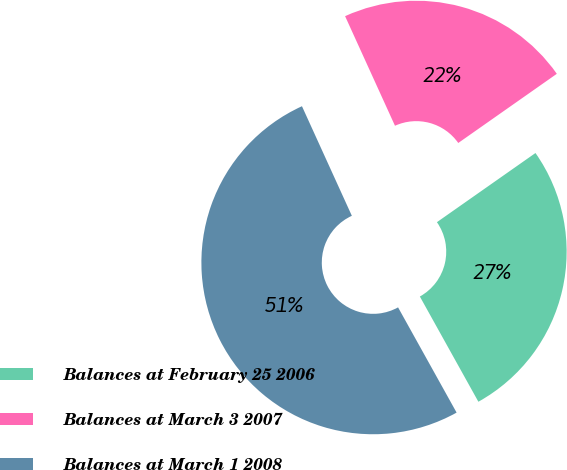<chart> <loc_0><loc_0><loc_500><loc_500><pie_chart><fcel>Balances at February 25 2006<fcel>Balances at March 3 2007<fcel>Balances at March 1 2008<nl><fcel>26.66%<fcel>22.06%<fcel>51.28%<nl></chart> 